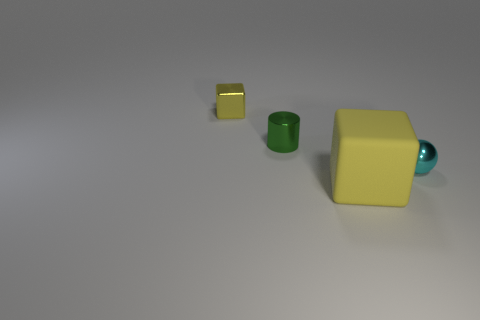Is there any other thing that is the same size as the yellow matte thing?
Give a very brief answer. No. Are there any other things that have the same color as the big object?
Offer a very short reply. Yes. There is a rubber object; is its color the same as the block behind the cyan ball?
Provide a short and direct response. Yes. Are there any other things that are the same material as the large cube?
Ensure brevity in your answer.  No. The metallic object that is the same color as the large block is what size?
Your answer should be compact. Small. There is a shiny object behind the green metallic thing; is it the same shape as the green thing?
Offer a terse response. No. Are there more big yellow cubes that are on the right side of the tiny metal block than green metallic cylinders in front of the small sphere?
Provide a succinct answer. Yes. What number of yellow matte objects are left of the tiny thing that is in front of the tiny cylinder?
Give a very brief answer. 1. There is a large block that is the same color as the tiny block; what material is it?
Keep it short and to the point. Rubber. How many other things are there of the same color as the large block?
Ensure brevity in your answer.  1. 